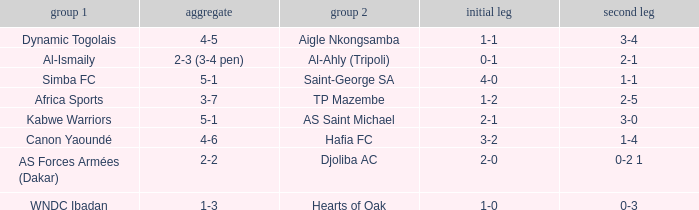What team played against Hafia FC (team 2)? Canon Yaoundé. Could you parse the entire table as a dict? {'header': ['group 1', 'aggregate', 'group 2', 'initial leg', 'second leg'], 'rows': [['Dynamic Togolais', '4-5', 'Aigle Nkongsamba', '1-1', '3-4'], ['Al-Ismaily', '2-3 (3-4 pen)', 'Al-Ahly (Tripoli)', '0-1', '2-1'], ['Simba FC', '5-1', 'Saint-George SA', '4-0', '1-1'], ['Africa Sports', '3-7', 'TP Mazembe', '1-2', '2-5'], ['Kabwe Warriors', '5-1', 'AS Saint Michael', '2-1', '3-0'], ['Canon Yaoundé', '4-6', 'Hafia FC', '3-2', '1-4'], ['AS Forces Armées (Dakar)', '2-2', 'Djoliba AC', '2-0', '0-2 1'], ['WNDC Ibadan', '1-3', 'Hearts of Oak', '1-0', '0-3']]} 